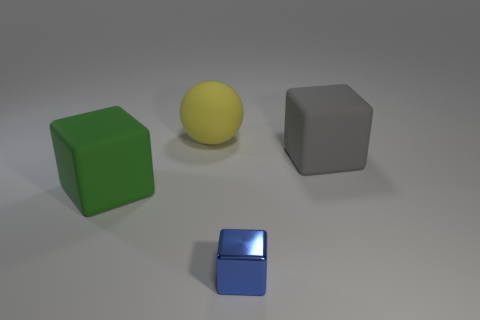Can you describe the lighting and mood of the scene depicted in the image? The scene has a soft and diffuse lighting that creates gentle shadows on the ground. This contributes to a serene and somewhat neutral mood, highlighting the objects without causing any harsh contrasts or intense reflections, save for the slight shine on the blue cube. 